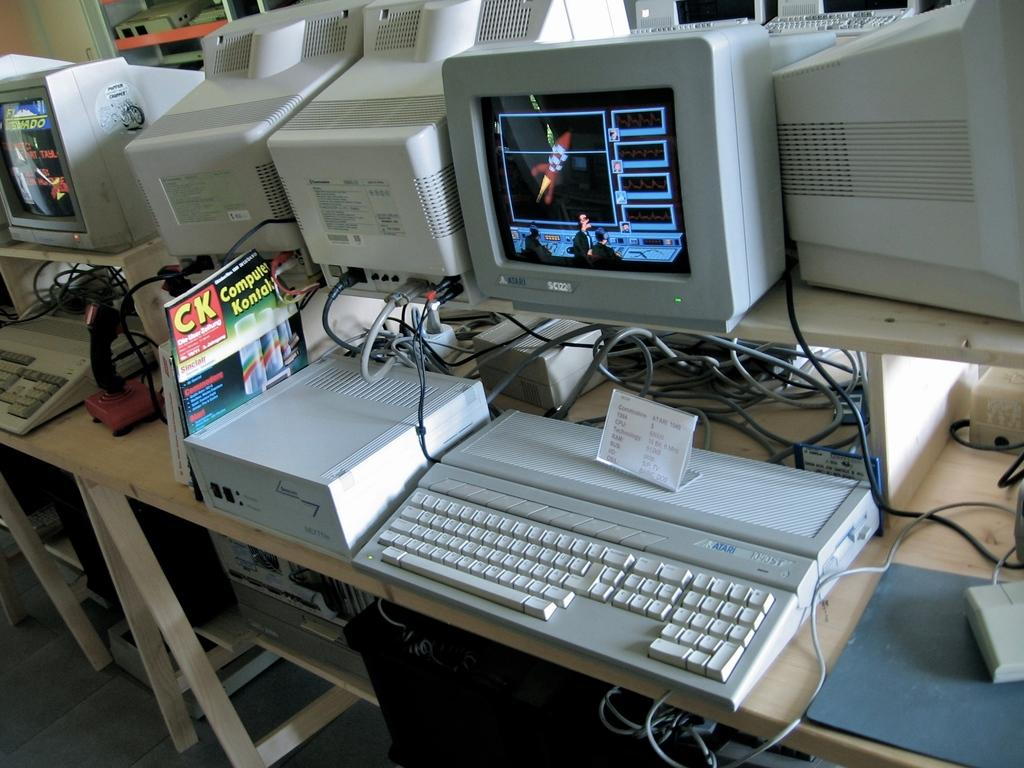<image>
Write a terse but informative summary of the picture. A computer and keyboard with a CK - Computer Kontal magazine next to it. 